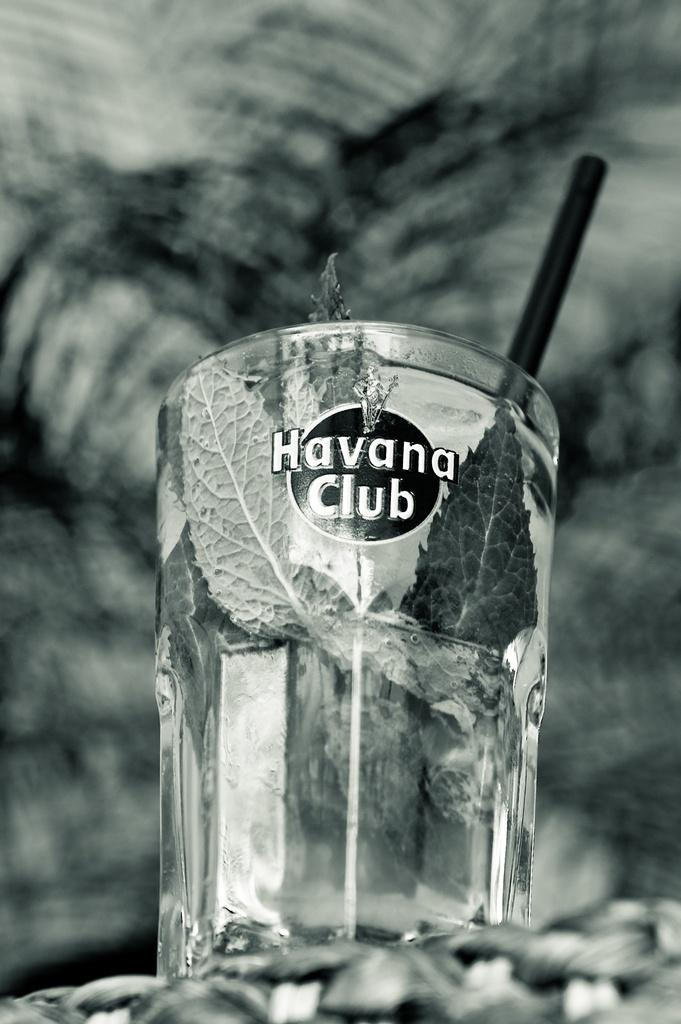What is inside the glass that is visible in the image? There is a drink in the glass in the image. What else can be seen inside the glass? There are leaves and a straw in the glass. How would you describe the background of the image? The background of the image is blurred. What is the color scheme of the image? The image is black and white. What type of wound can be seen on the guitar in the image? There is no guitar present in the image, so it is not possible to determine if there is a wound on it. 